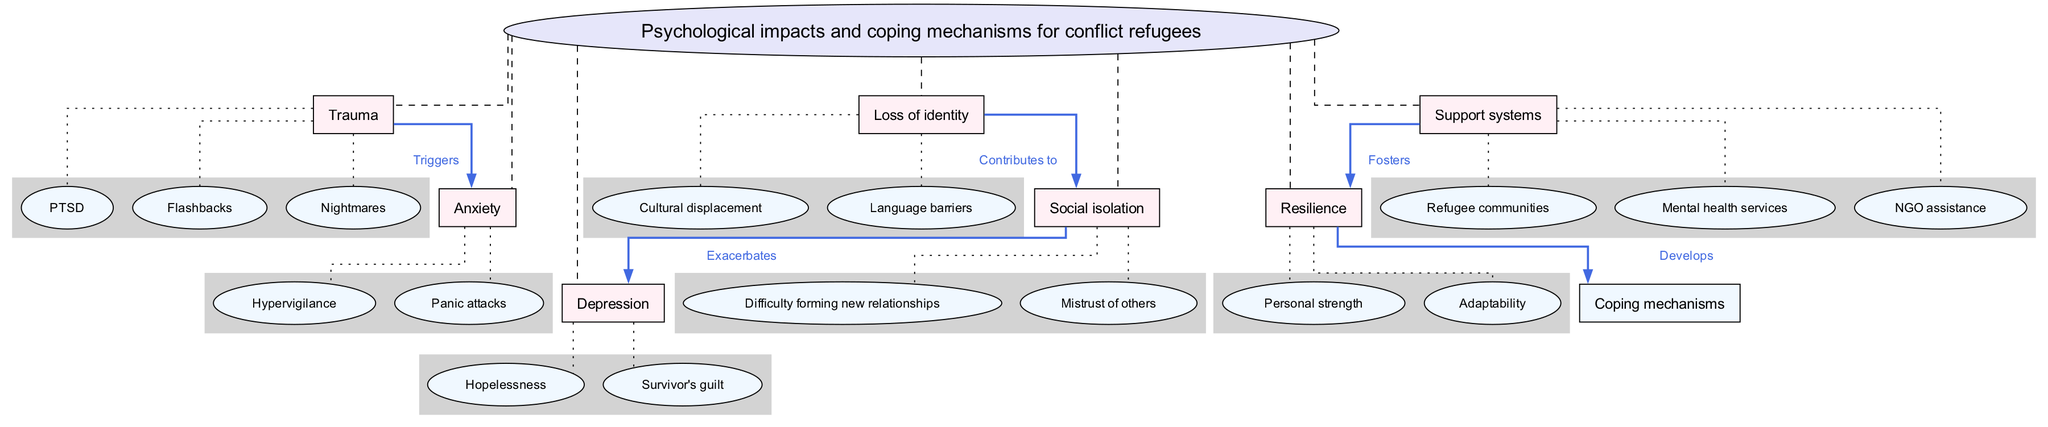What's the central concept of the diagram? The central concept is represented in an ellipse at the top of the diagram, labeled "Psychological impacts and coping mechanisms for conflict refugees".
Answer: Psychological impacts and coping mechanisms for conflict refugees How many main nodes are there? The diagram shows a total of seven main nodes branching from the central concept. These nodes are distinct and labeled, which is a clear indication of their count.
Answer: 7 What connection is indicated between Trauma and Anxiety? The diagram shows a directed edge connecting the nodes "Trauma" and "Anxiety", labeled "Triggers", indicating that trauma can trigger anxiety responses.
Answer: Triggers Which sub-node corresponds to Depression? Among the sub-nodes under Depression, "Hopelessness" and "Survivor's guilt" are provided, with the information easily gleaned from the connections beneath the main node "Depression".
Answer: Hopelessness (or Survivor's guilt; either is correct) What do Support systems foster? The edge labeled "Fosters" connects "Support systems" to "Resilience", indicating that support systems help foster resilience among individuals fleeing conflict zones.
Answer: Resilience How does Loss of identity contribute to Social isolation? The diagram presents a connection showing that "Loss of identity" leads to "Social isolation" with a labeled edge "Contributes to", illustrating a direct relationship between these two nodes.
Answer: Contributes to What are two examples of sub-nodes under the node Resilience? According to the diagram, sub-nodes under Resilience include "Personal strength" and "Adaptability", clearly listed under the main node Resilience for easy identification.
Answer: Personal strength and Adaptability What is the relationship between Social isolation and Depression? The diagram describes how social isolation exacerbates depression through a directed edge with the label "Exacerbates", indicating that one condition intensifies the other.
Answer: Exacerbates Name a coping mechanism developed from Resilience. The diagram specifies that coping mechanisms are developed from resilience, although it does not list them explicitly; however, the implication is that resilience fosters effective coping strategies.
Answer: Coping mechanisms 